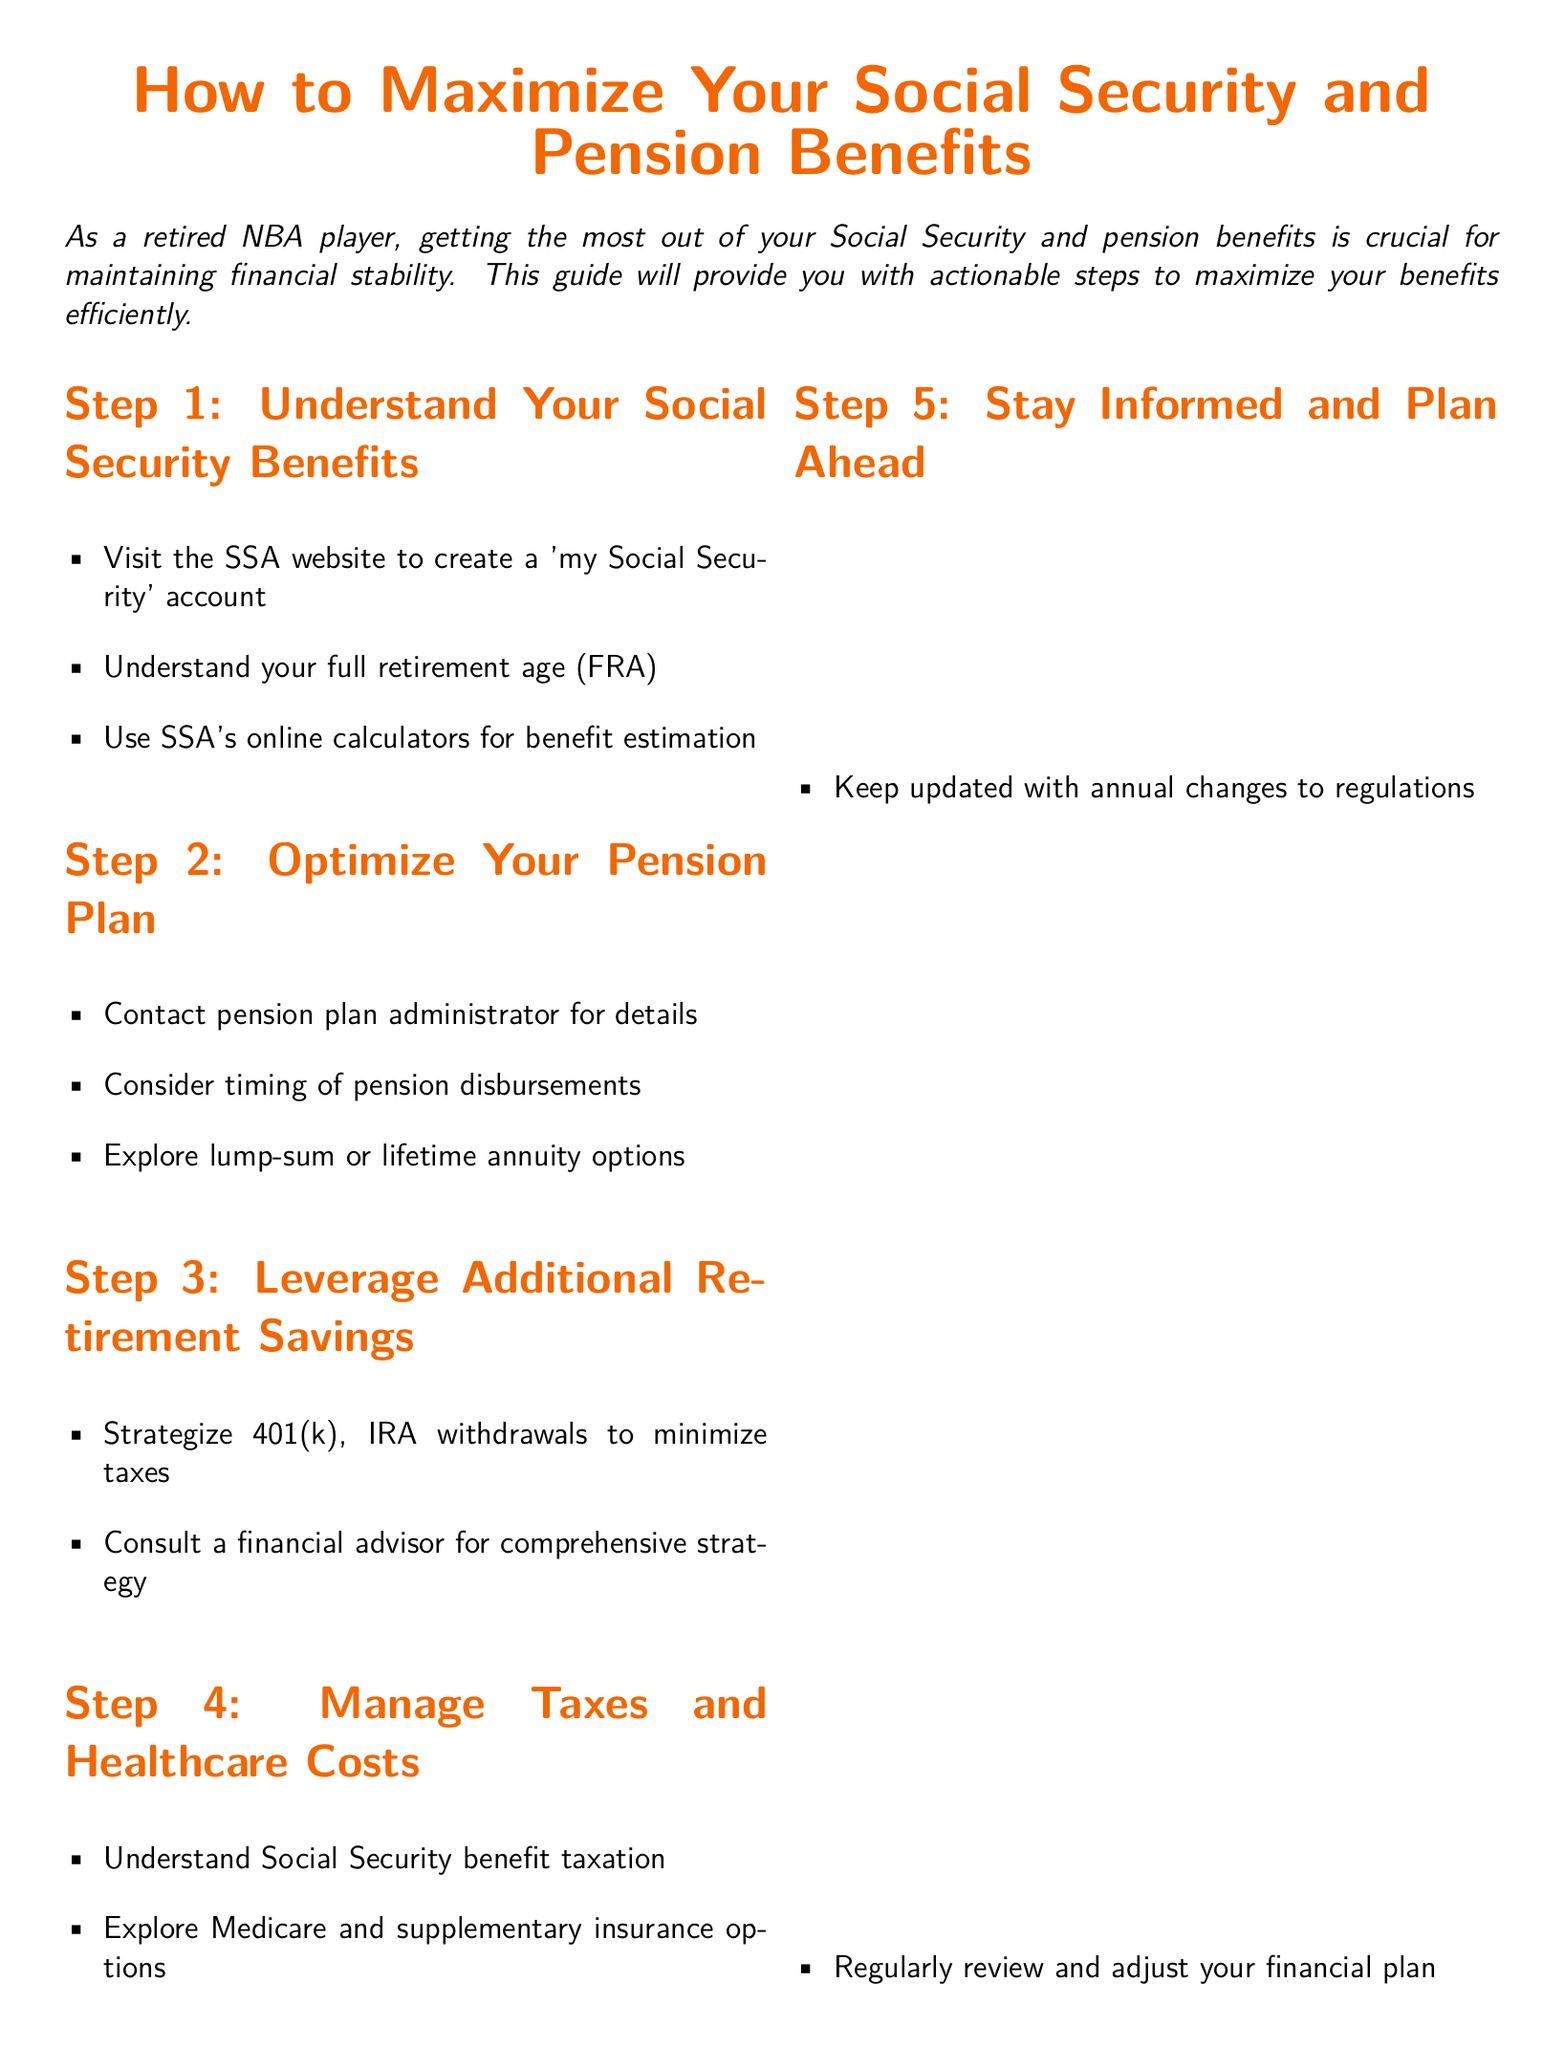What is the title of the guide? The title of the guide is prominently displayed at the top of the document.
Answer: How to Maximize Your Social Security and Pension Benefits What is the first step in maximizing benefits? The first step is outlined in the first section, which emphasizes understanding a key aspect of Social Security.
Answer: Understand Your Social Security Benefits Where can you create a 'my Social Security' account? The document suggests visiting a specific website related to Social Security.
Answer: SSA website What should you consider regarding your pension plan? The second step lists an important action regarding pension plans that affects timing.
Answer: Timing of pension disbursements What book is recommended for understanding Social Security? The document includes a section listing suggested reading materials.
Answer: Social Security Made Simple by Mike Piper What color is used for the title text? The document specifies a color code for the title in its formatting.
Answer: basketorange How often should you review your financial plan? The last step suggests a frequency for reviewing your financial status.
Answer: Regularly What is one way to manage healthcare costs mentioned in the document? The document provides options regarding healthcare management in one of the sections.
Answer: Explore Medicare and supplementary insurance options 